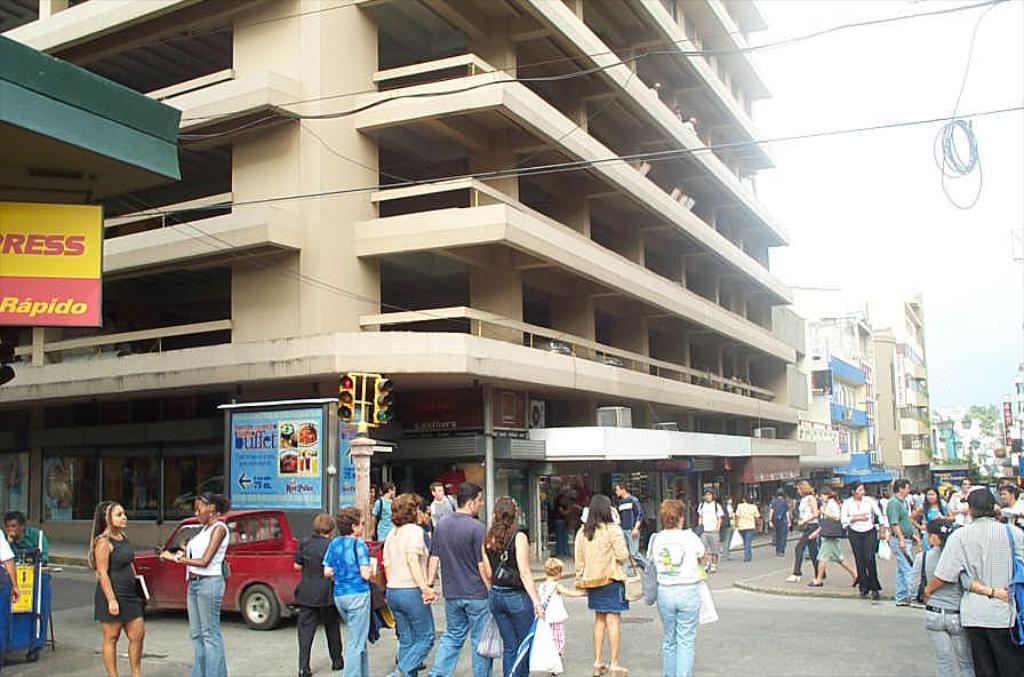Can you describe this image briefly? Here we can see group of people and there is a vehicle on the road. Here we can see buildings, poles, traffic signals, boards, and hoarding. In the background we can see sky. 